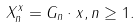<formula> <loc_0><loc_0><loc_500><loc_500>X _ { n } ^ { x } = G _ { n } \cdot x , n \geq 1 .</formula> 